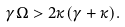<formula> <loc_0><loc_0><loc_500><loc_500>\gamma \Omega > 2 \kappa ( \gamma + \kappa ) .</formula> 